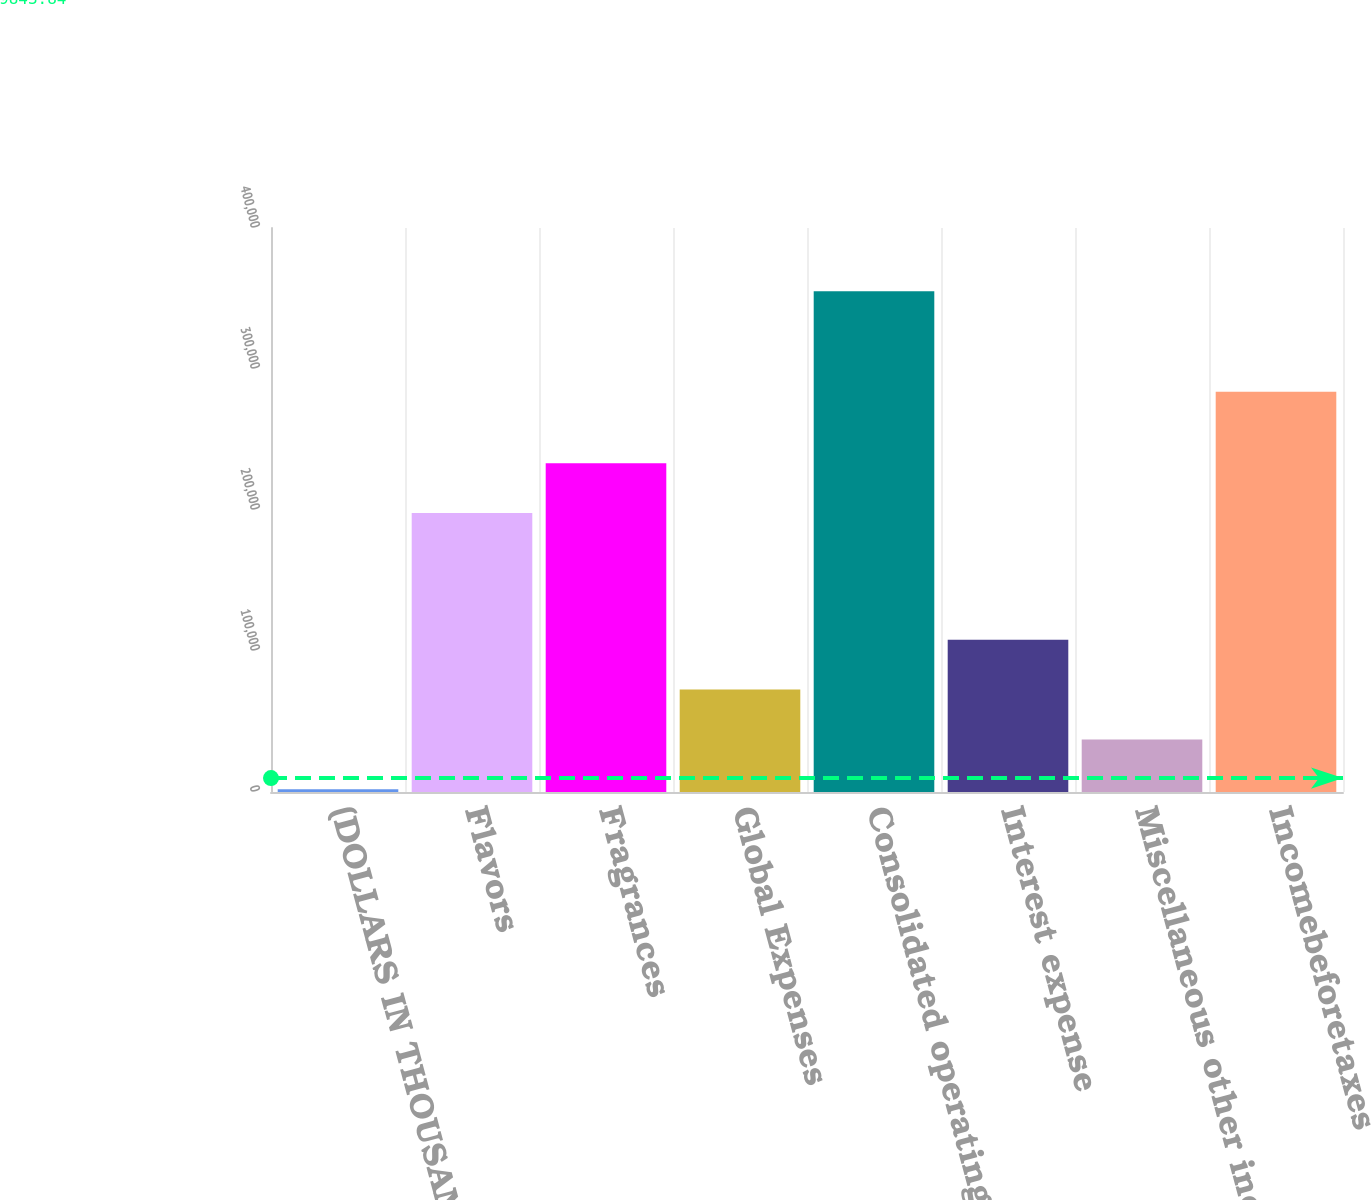Convert chart. <chart><loc_0><loc_0><loc_500><loc_500><bar_chart><fcel>(DOLLARS IN THOUSANDS)<fcel>Flavors<fcel>Fragrances<fcel>Global Expenses<fcel>Consolidated operating income<fcel>Interest expense<fcel>Miscellaneous other income<fcel>Incomebeforetaxes<nl><fcel>2008<fcel>197838<fcel>233150<fcel>72633<fcel>355133<fcel>107946<fcel>37320.5<fcel>283922<nl></chart> 